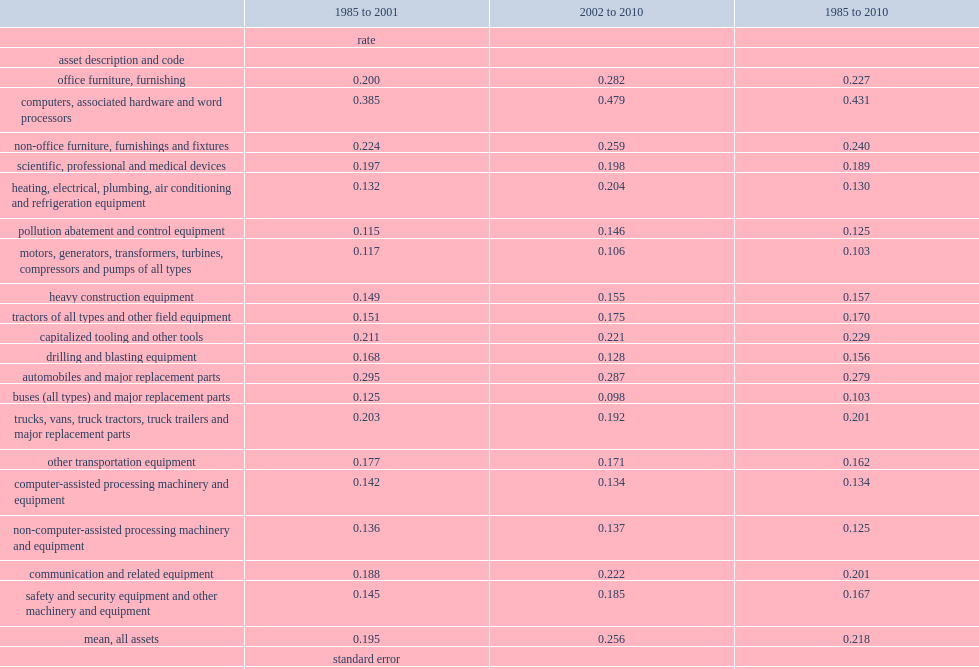The mean depreciation rate for these selected machinery and equipment categories as a whole, weighted by their chained dollar investment shares, what was the percentage increased from 1985 to 2001? 0.195. The mean depreciation rate for these selected machinery and equipment categories as a whole, weighted by their chained dollar investment shares, what was the percentage increased from 2002 to 2010? 0.256. 